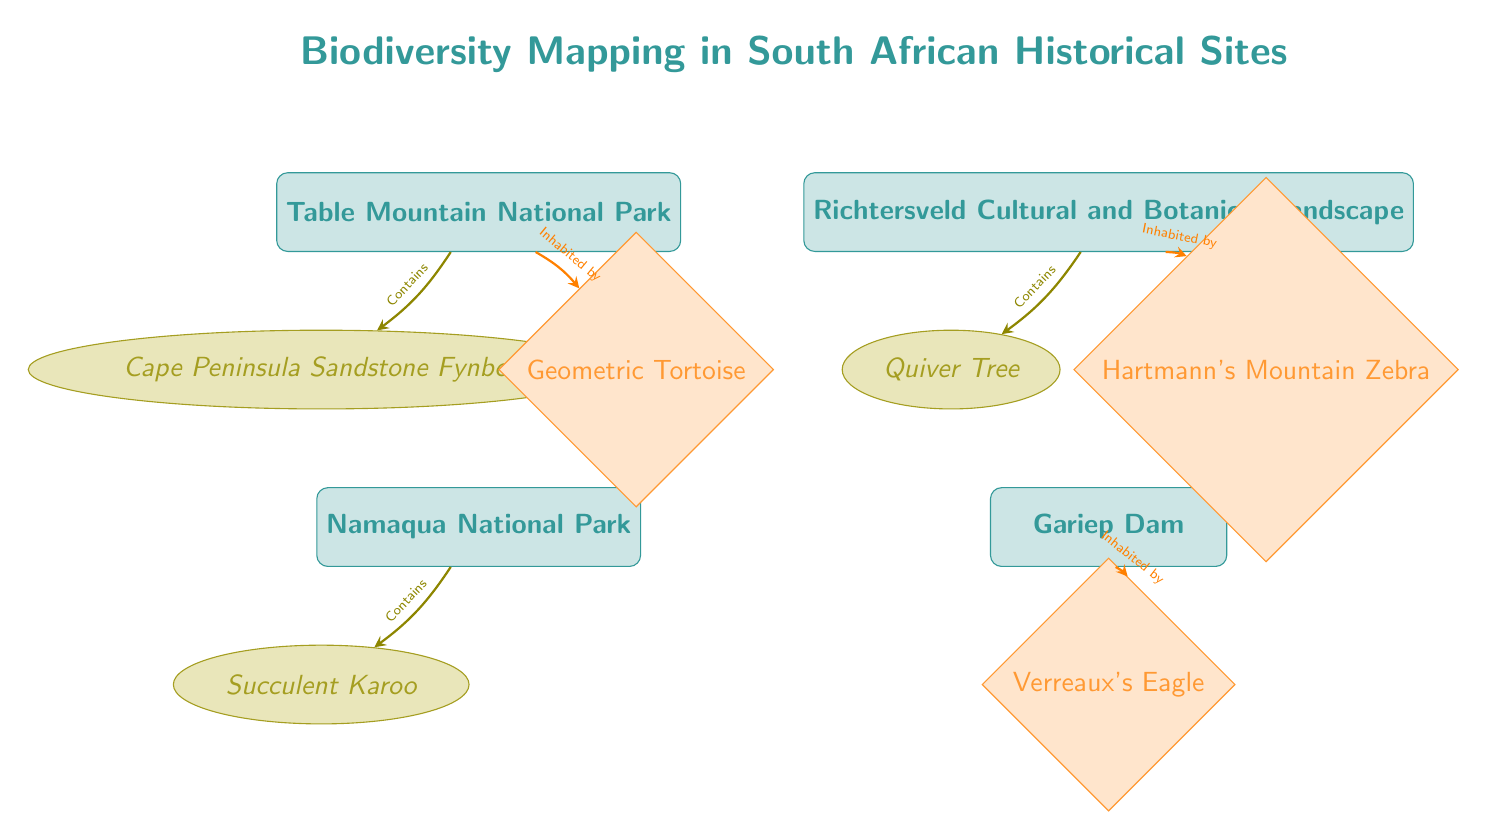What are the names of the two locations shown in the diagram? The two locations seen in the diagram are Table Mountain National Park and Richtersveld Cultural and Botanical Landscape. They are the first two nodes positioned at the top left and top right.
Answer: Table Mountain National Park, Richtersveld Cultural and Botanical Landscape How many locations are featured in this biodiversity mapping? The diagram displays four locations in total, represented by the four rectangle nodes at the top and bottom of the diagram.
Answer: 4 Which species is associated with Namaqua National Park? The species linked to Namaqua National Park is the Succulent Karoo, as indicated beneath the location node in the diagram.
Answer: Succulent Karoo What types of organisms are represented in the diagram? The diagram categorizes species into two types: Flora and Fauna, as seen in the different shapes and colors used for each type in the diagram.
Answer: Flora and Fauna What species can be found at Table Mountain National Park? The species that inhabit Table Mountain National Park include the Cape Peninsula Sandstone Fynbos and the Geometric Tortoise, as shown next to the location node.
Answer: Cape Peninsula Sandstone Fynbos, Geometric Tortoise Which location is inhabited by Hartmann's Mountain Zebra? Hartmann's Mountain Zebra is found at the Richtersveld Cultural and Botanical Landscape, as indicated by the connecting arrow from the location node to the respective fauna node.
Answer: Richtersveld Cultural and Botanical Landscape How is the relationship between Table Mountain and Geometric Tortoise expressed in the diagram? The relationship is expressed with an arrow indicating that the Geometric Tortoise inhabits Table Mountain National Park, with a label stating “Inhabited by.”
Answer: Inhabited by Which location does not have a flora representation in the diagram? Gariep Dam does not have a flora representation, as it connects only to the fauna node and lacks an associated flora node.
Answer: Gariep Dam What is the color used for Fauna categories in the diagram? The color used for Fauna categories in the diagram is orange, as seen in the shaded diamonds for fauna species.
Answer: Orange 